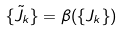<formula> <loc_0><loc_0><loc_500><loc_500>\{ \tilde { J } _ { k } \} = \beta ( \{ J _ { k } \} )</formula> 